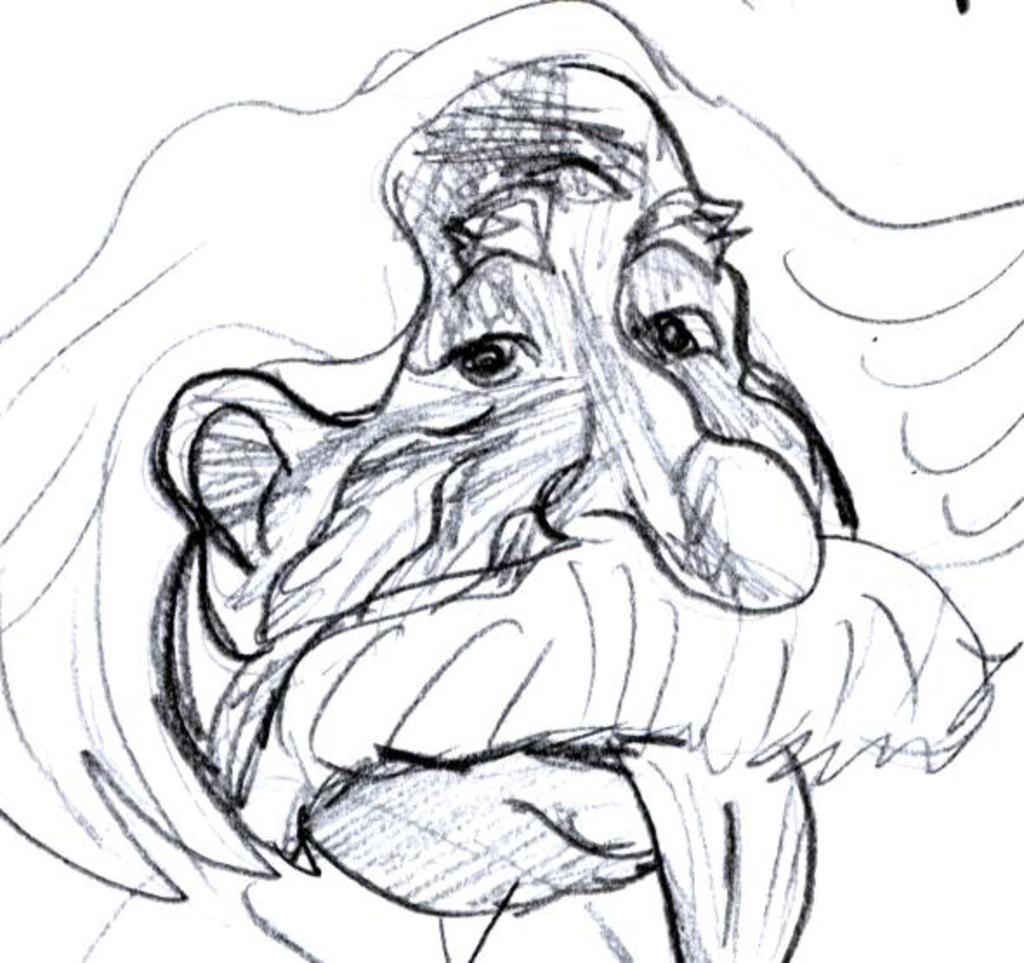In one or two sentences, can you explain what this image depicts? We can see drawing of person face. 